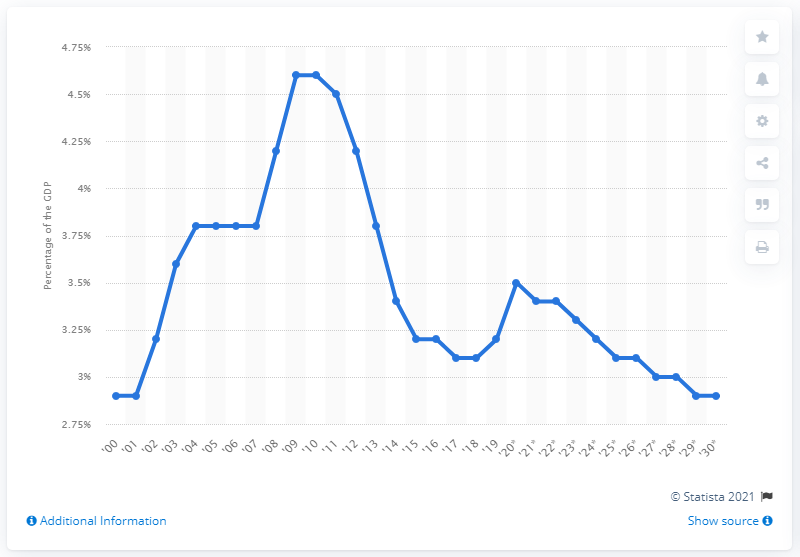Indicate a few pertinent items in this graphic. In 2019, defense outlays accounted for 3.2% of the total Gross Domestic Product (GDP) of the United States. The U.S. GDP would increase by 2.9% if 888 billion U.S. dollars were added to the economy in 2030. 